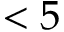<formula> <loc_0><loc_0><loc_500><loc_500>< 5</formula> 